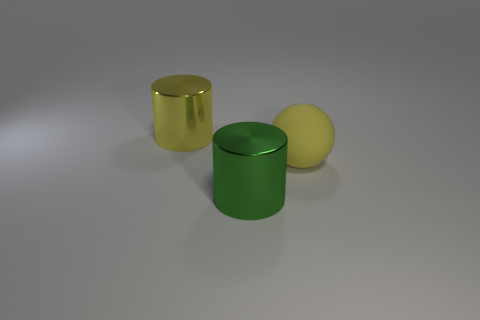There is a cylinder that is the same color as the big sphere; what material is it?
Provide a succinct answer. Metal. How many large metallic objects have the same shape as the yellow matte object?
Make the answer very short. 0. Is the material of the big sphere the same as the large thing that is on the left side of the green shiny cylinder?
Offer a terse response. No. How many small gray shiny objects are there?
Provide a short and direct response. 0. There is a metallic cylinder in front of the large matte sphere; what size is it?
Make the answer very short. Large. What number of yellow objects are the same size as the yellow shiny cylinder?
Ensure brevity in your answer.  1. There is a big thing that is left of the ball and in front of the yellow cylinder; what material is it made of?
Provide a succinct answer. Metal. What material is the green cylinder that is the same size as the yellow rubber object?
Give a very brief answer. Metal. What is the size of the cylinder in front of the big yellow thing in front of the thing that is left of the large green metallic thing?
Your answer should be very brief. Large. What size is the other cylinder that is the same material as the large yellow cylinder?
Provide a succinct answer. Large. 